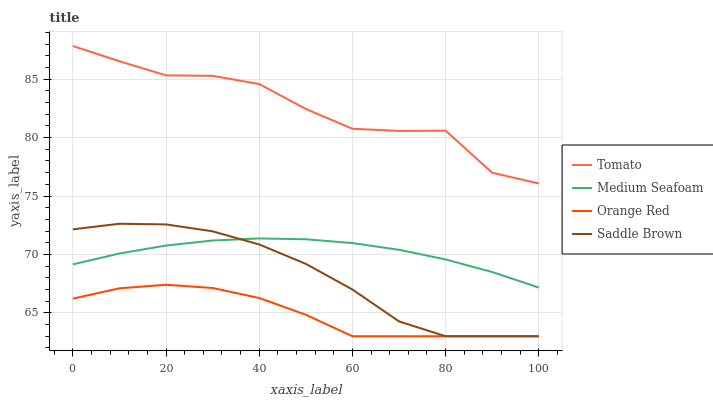Does Orange Red have the minimum area under the curve?
Answer yes or no. Yes. Does Tomato have the maximum area under the curve?
Answer yes or no. Yes. Does Saddle Brown have the minimum area under the curve?
Answer yes or no. No. Does Saddle Brown have the maximum area under the curve?
Answer yes or no. No. Is Medium Seafoam the smoothest?
Answer yes or no. Yes. Is Tomato the roughest?
Answer yes or no. Yes. Is Saddle Brown the smoothest?
Answer yes or no. No. Is Saddle Brown the roughest?
Answer yes or no. No. Does Medium Seafoam have the lowest value?
Answer yes or no. No. Does Tomato have the highest value?
Answer yes or no. Yes. Does Saddle Brown have the highest value?
Answer yes or no. No. Is Orange Red less than Medium Seafoam?
Answer yes or no. Yes. Is Medium Seafoam greater than Orange Red?
Answer yes or no. Yes. Does Saddle Brown intersect Orange Red?
Answer yes or no. Yes. Is Saddle Brown less than Orange Red?
Answer yes or no. No. Is Saddle Brown greater than Orange Red?
Answer yes or no. No. Does Orange Red intersect Medium Seafoam?
Answer yes or no. No. 